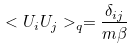Convert formula to latex. <formula><loc_0><loc_0><loc_500><loc_500>< U _ { i } U _ { j } > _ { q } = \frac { \delta _ { i j } } { m \beta }</formula> 